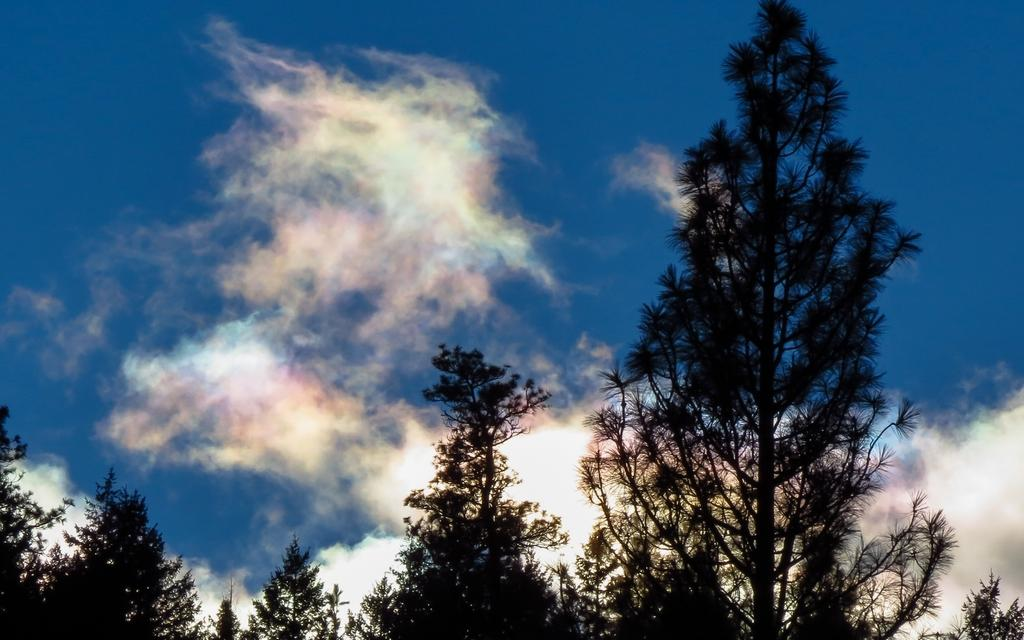What type of vegetation can be seen in the image? There are trees in the image. What is visible in the sky in the image? The sky is clouded in the image. What emotion can be seen on the trees in the image? Trees do not have emotions, so it is not possible to determine an emotion from the image. How does the love between the trees manifest in the image? Love is a human emotion and cannot be attributed to trees; therefore, it cannot be observed in the image. 